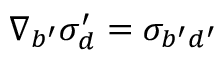<formula> <loc_0><loc_0><loc_500><loc_500>\nabla _ { b ^ { \prime } } \sigma _ { d } ^ { \prime } = \sigma _ { b ^ { \prime } d ^ { \prime } }</formula> 